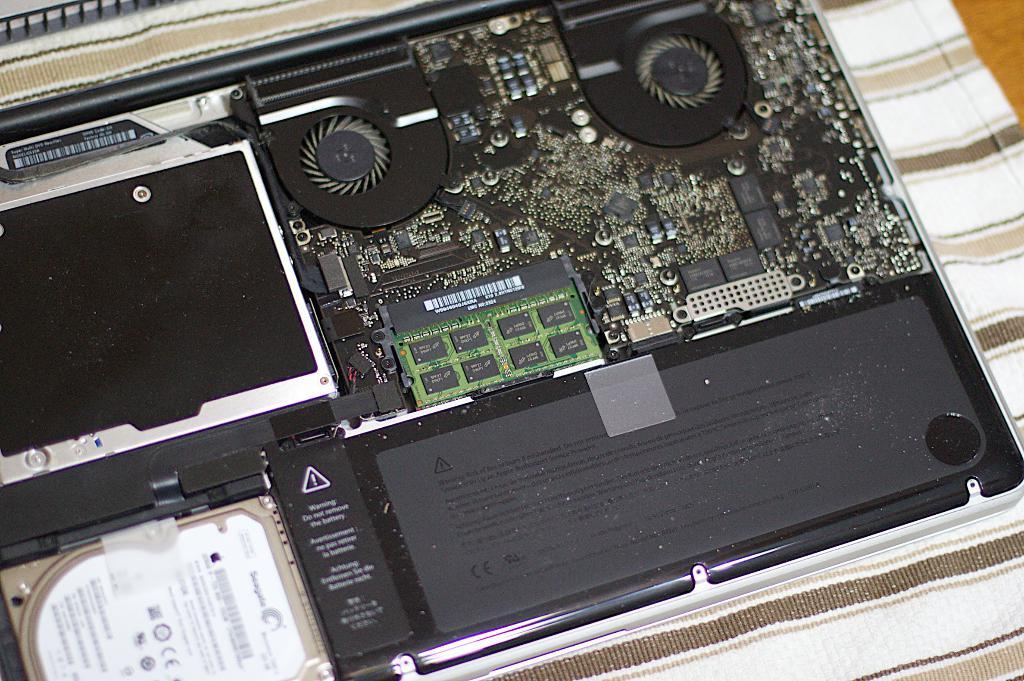<image>
Render a clear and concise summary of the photo. The inside of a computer contains a black plate that warns you "do not remove battery." 